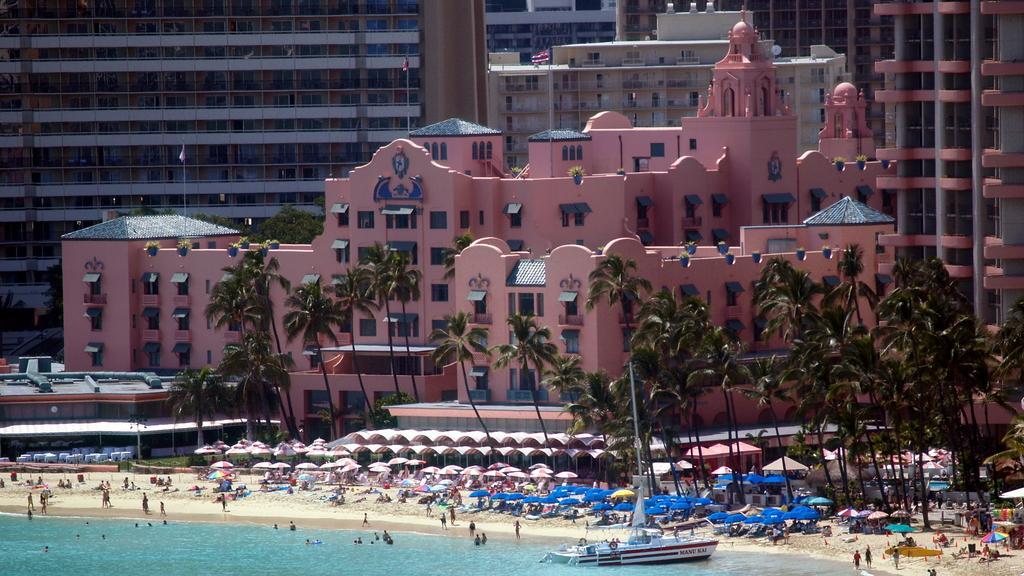Please provide a concise description of this image. In this image we can see some buildings, flags, trees, there are some umbrellas, tents, people on the seashore, also we can see the sky and a boat on the sea. 